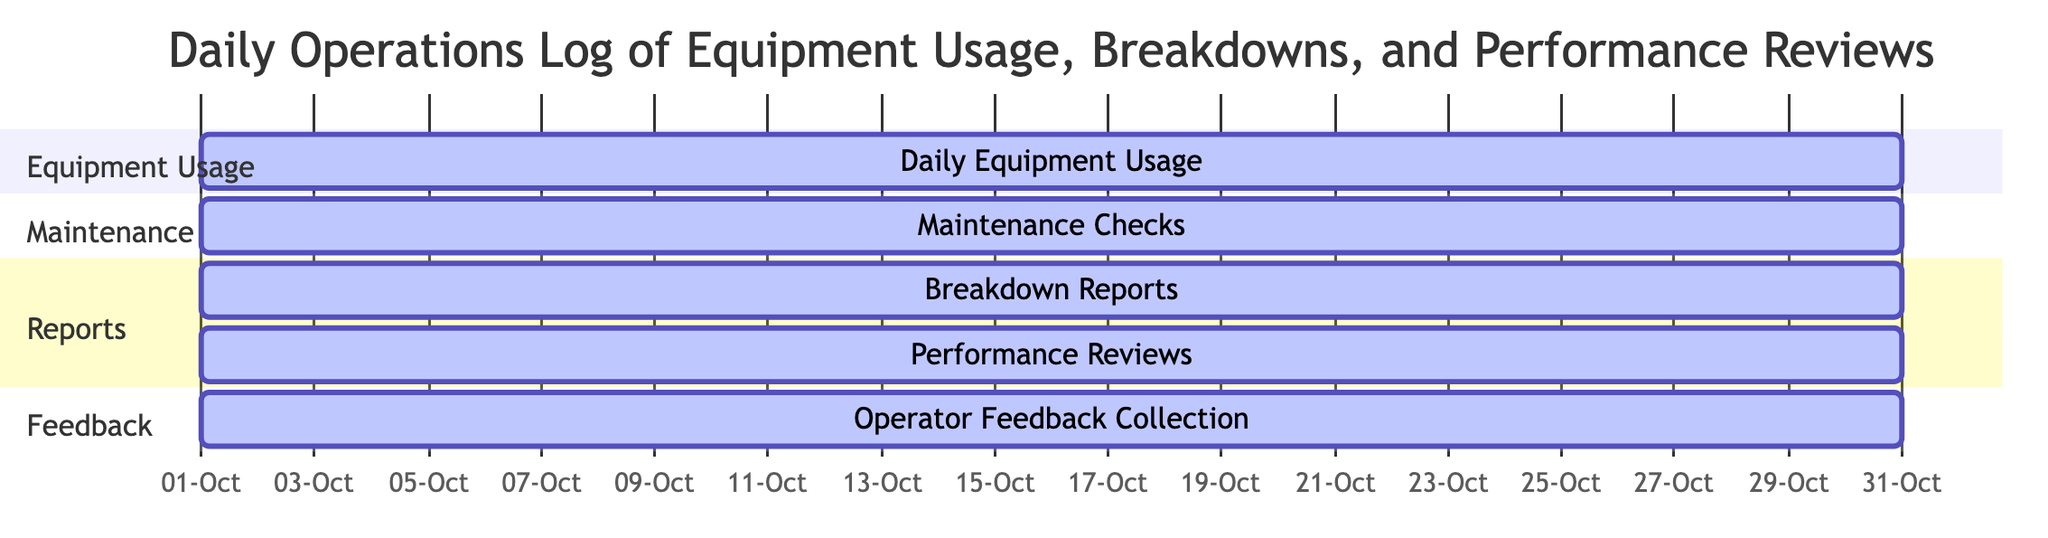What are the tasks included in the daily operations log? The Gantt Chart lists several tasks including Daily Equipment Usage, Breakdown Reports, Performance Reviews, Maintenance Checks, and Operator Feedback Collection.
Answer: Daily Equipment Usage, Breakdown Reports, Performance Reviews, Maintenance Checks, Operator Feedback Collection How many sections are in the Gantt Chart? The Gantt Chart is divided into four sections: Equipment Usage, Maintenance, Reports, and Feedback. Each section contains one or more tasks.
Answer: Four Which tasks overlap in the schedule? All tasks listed in the Gantt Chart overlap in the schedule since they all start on the same date and last for the same duration of 30 days.
Answer: All tasks What is the duration of each task? Each task in the Gantt Chart has a duration of 30 days, as indicated in the chart’s details for each task.
Answer: Thirty days Which task focuses on equipment failures? The task dedicated to equipment failures is called Breakdown Reports, as specified in the task descriptions on the chart.
Answer: Breakdown Reports How many tasks are scheduled to be performed simultaneously? Since all tasks are scheduled to run for the full duration of 30 days simultaneously, there are five tasks that are performed at the same time.
Answer: Five Which section contains the task related to usability evaluation? The task related to usability evaluation, Performance Reviews, is found in the Reports section of the Gantt Chart.
Answer: Reports What is the start date for all tasks? The start date for all tasks in the Gantt Chart is October 1, 2023, as shown in the timeline information for each task.
Answer: October 1, 2023 Which section includes feedback from operators? Feedback from operators is included in the Feedback section, which specifically contains the Operator Feedback Collection task.
Answer: Feedback 